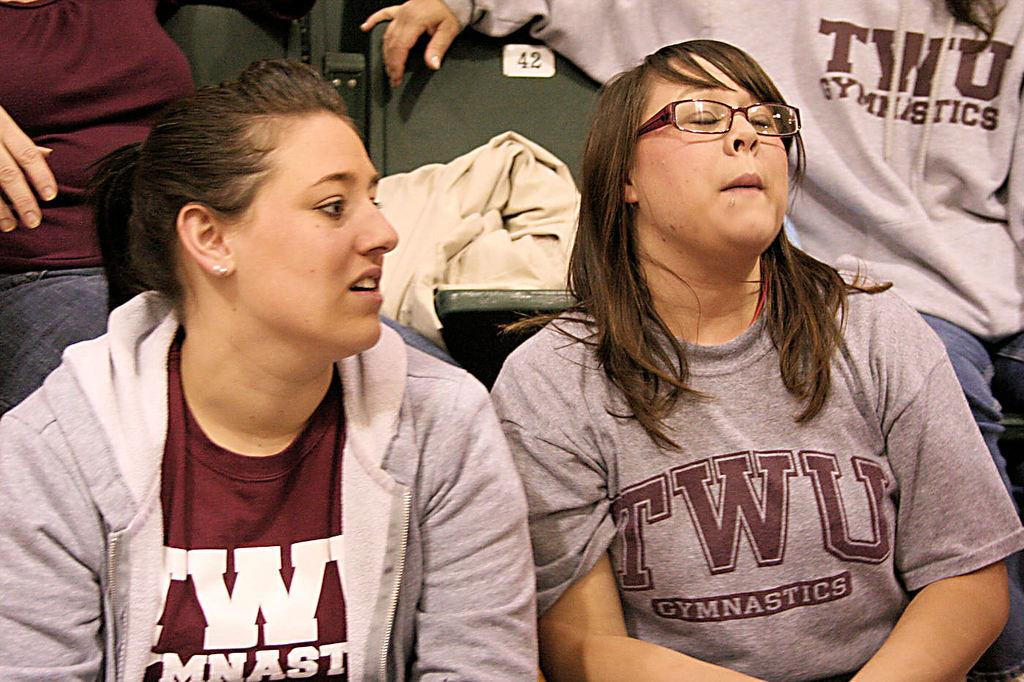What are the people in the image doing? The people in the image are sitting. What type of furniture is visible in the image? There is a chair with cloth on it. Are there any decorations or markings on the chair? Yes, there is a sticker on the chair. How many clouds can be seen on the chair in the image? There are no clouds visible on the chair in the image. What type of cloth is covering the ants in the image? There are no ants present in the image, and therefore no cloth covering them. 